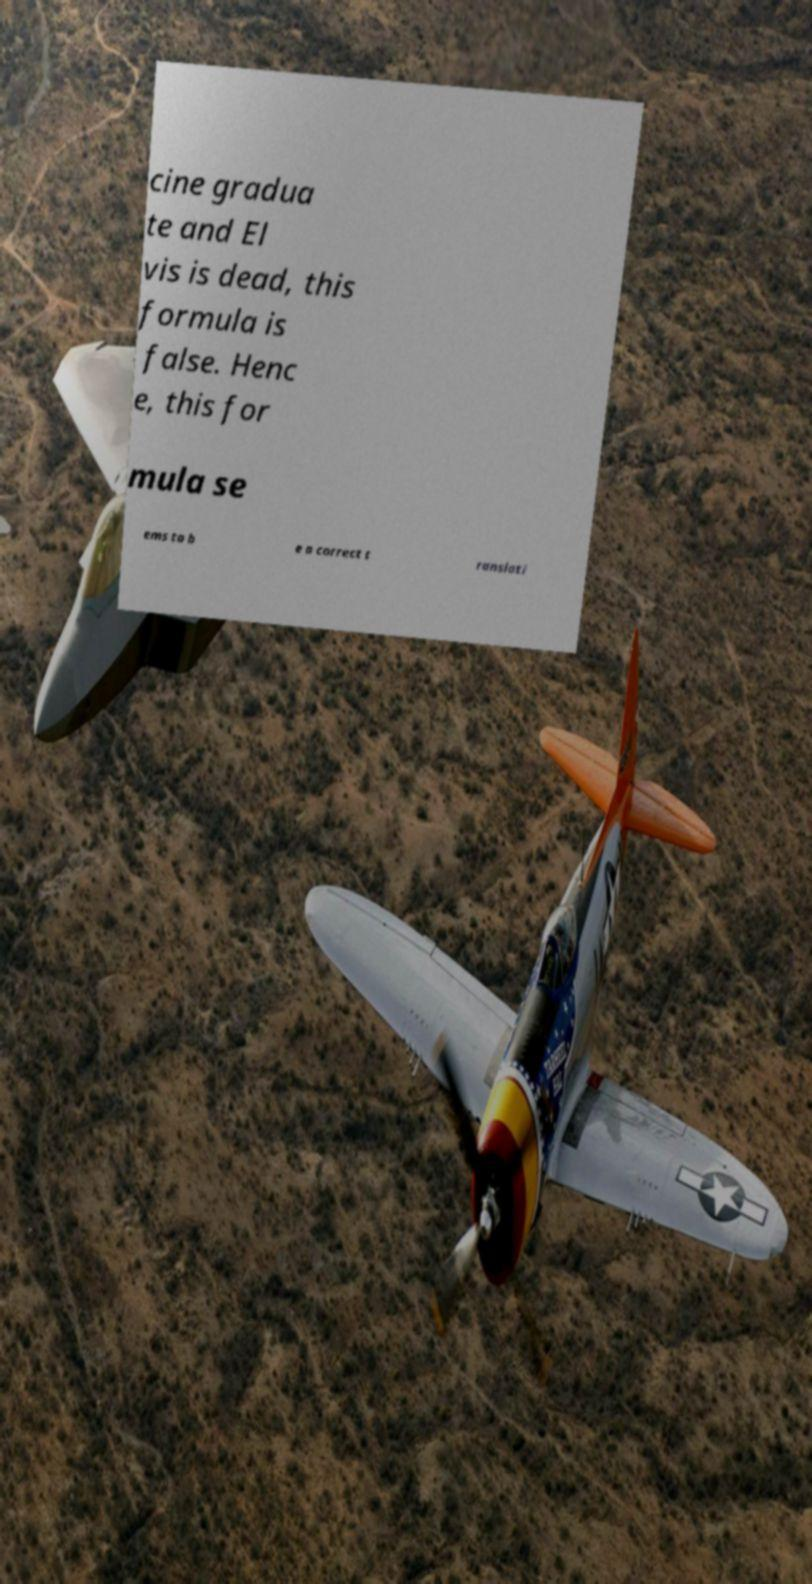There's text embedded in this image that I need extracted. Can you transcribe it verbatim? cine gradua te and El vis is dead, this formula is false. Henc e, this for mula se ems to b e a correct t ranslati 